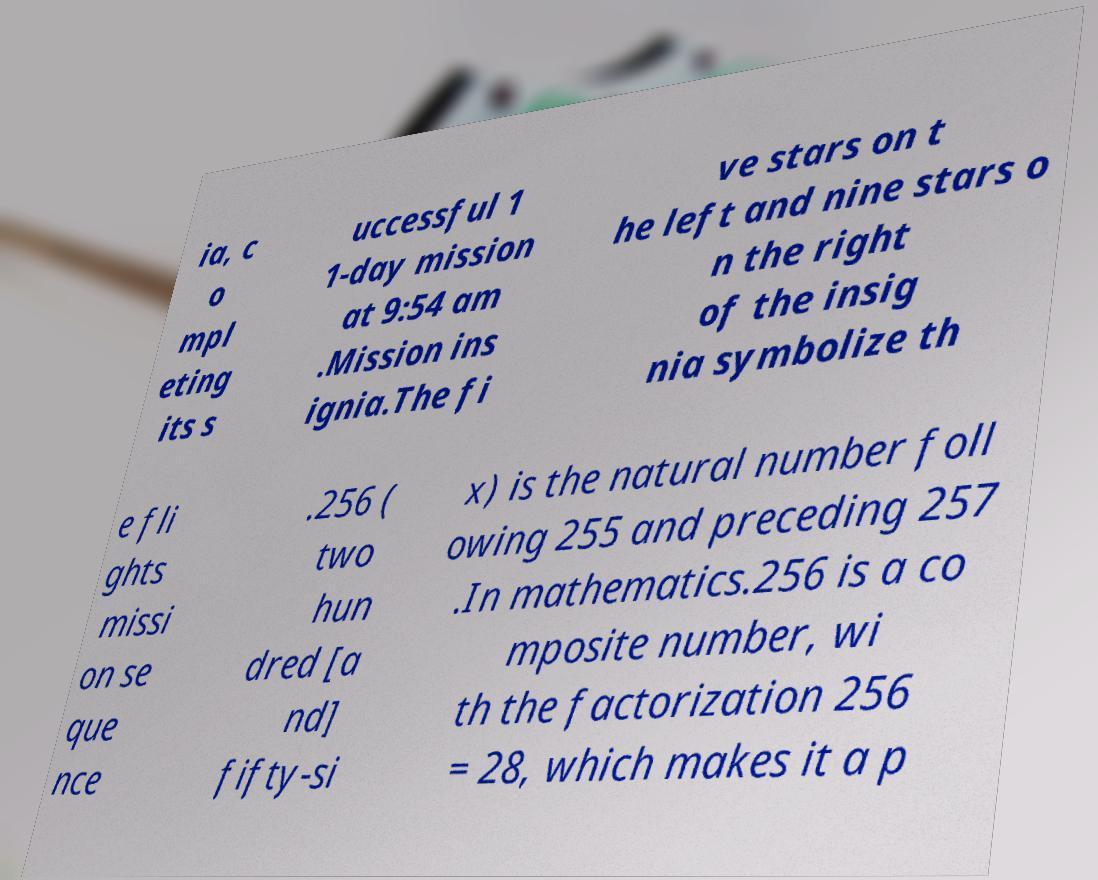There's text embedded in this image that I need extracted. Can you transcribe it verbatim? ia, c o mpl eting its s uccessful 1 1-day mission at 9:54 am .Mission ins ignia.The fi ve stars on t he left and nine stars o n the right of the insig nia symbolize th e fli ghts missi on se que nce .256 ( two hun dred [a nd] fifty-si x) is the natural number foll owing 255 and preceding 257 .In mathematics.256 is a co mposite number, wi th the factorization 256 = 28, which makes it a p 